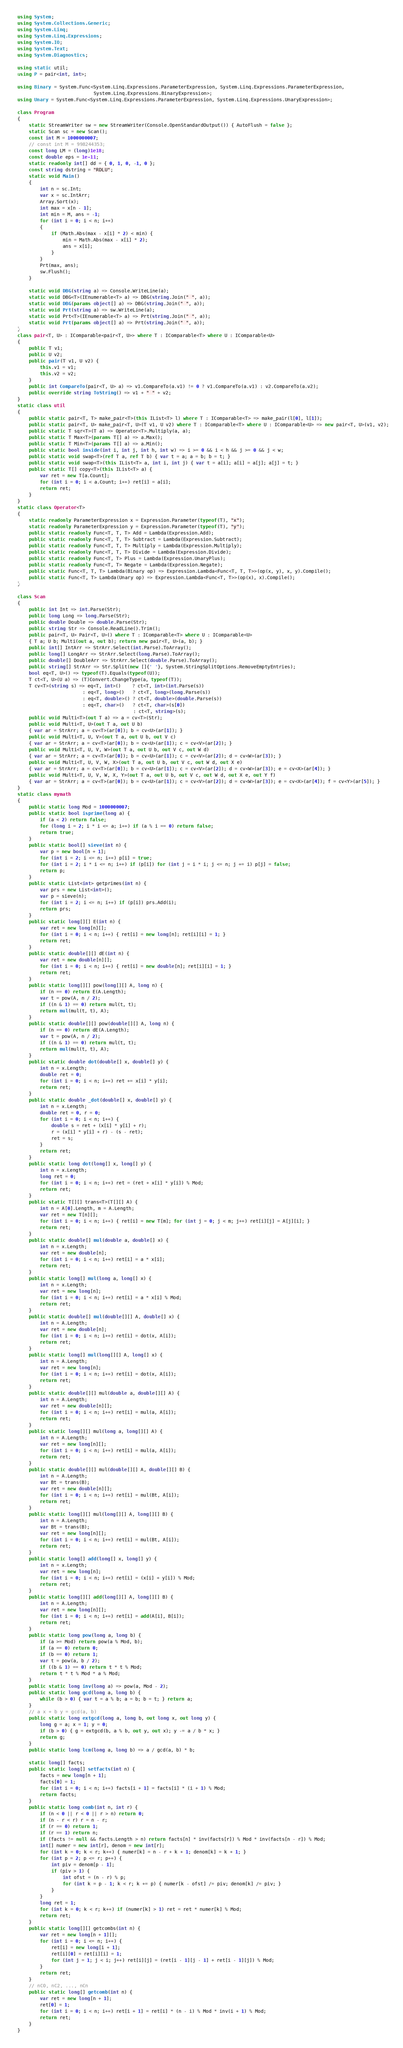<code> <loc_0><loc_0><loc_500><loc_500><_C#_>using System;
using System.Collections.Generic;
using System.Linq;
using System.Linq.Expressions;
using System.IO;
using System.Text;
using System.Diagnostics;

using static util;
using P = pair<int, int>;

using Binary = System.Func<System.Linq.Expressions.ParameterExpression, System.Linq.Expressions.ParameterExpression,
                           System.Linq.Expressions.BinaryExpression>;
using Unary = System.Func<System.Linq.Expressions.ParameterExpression, System.Linq.Expressions.UnaryExpression>;

class Program
{
    static StreamWriter sw = new StreamWriter(Console.OpenStandardOutput()) { AutoFlush = false };
    static Scan sc = new Scan();
    const int M = 1000000007;
    // const int M = 998244353;
    const long LM = (long)1e18;
    const double eps = 1e-11;
    static readonly int[] dd = { 0, 1, 0, -1, 0 };
    const string dstring = "RDLU";
    static void Main()
    {
        int n = sc.Int;
        var x = sc.IntArr;
        Array.Sort(x);
        int max = x[n - 1];
        int min = M, ans = -1;
        for (int i = 0; i < n; i++)
        {
            if (Math.Abs(max - x[i] * 2) < min) {
                min = Math.Abs(max - x[i] * 2);
                ans = x[i];
            }
        }
        Prt(max, ans);
        sw.Flush();
    }

    static void DBG(string a) => Console.WriteLine(a);
    static void DBG<T>(IEnumerable<T> a) => DBG(string.Join(" ", a));
    static void DBG(params object[] a) => DBG(string.Join(" ", a));
    static void Prt(string a) => sw.WriteLine(a);
    static void Prt<T>(IEnumerable<T> a) => Prt(string.Join(" ", a));
    static void Prt(params object[] a) => Prt(string.Join(" ", a));
}
class pair<T, U> : IComparable<pair<T, U>> where T : IComparable<T> where U : IComparable<U>
{
    public T v1;
    public U v2;
    public pair(T v1, U v2) {
        this.v1 = v1;
        this.v2 = v2;
    }
    public int CompareTo(pair<T, U> a) => v1.CompareTo(a.v1) != 0 ? v1.CompareTo(a.v1) : v2.CompareTo(a.v2);
    public override string ToString() => v1 + " " + v2;
}
static class util
{
    public static pair<T, T> make_pair<T>(this IList<T> l) where T : IComparable<T> => make_pair(l[0], l[1]);
    public static pair<T, U> make_pair<T, U>(T v1, U v2) where T : IComparable<T> where U : IComparable<U> => new pair<T, U>(v1, v2);
    public static T sqr<T>(T a) => Operator<T>.Multiply(a, a);
    public static T Max<T>(params T[] a) => a.Max();
    public static T Min<T>(params T[] a) => a.Min();
    public static bool inside(int i, int j, int h, int w) => i >= 0 && i < h && j >= 0 && j < w;
    public static void swap<T>(ref T a, ref T b) { var t = a; a = b; b = t; }
    public static void swap<T>(this IList<T> a, int i, int j) { var t = a[i]; a[i] = a[j]; a[j] = t; }
    public static T[] copy<T>(this IList<T> a) {
        var ret = new T[a.Count];
        for (int i = 0; i < a.Count; i++) ret[i] = a[i];
        return ret;
    }
}
static class Operator<T>
{
    static readonly ParameterExpression x = Expression.Parameter(typeof(T), "x");
    static readonly ParameterExpression y = Expression.Parameter(typeof(T), "y");
    public static readonly Func<T, T, T> Add = Lambda(Expression.Add);
    public static readonly Func<T, T, T> Subtract = Lambda(Expression.Subtract);
    public static readonly Func<T, T, T> Multiply = Lambda(Expression.Multiply);
    public static readonly Func<T, T, T> Divide = Lambda(Expression.Divide);
    public static readonly Func<T, T> Plus = Lambda(Expression.UnaryPlus);
    public static readonly Func<T, T> Negate = Lambda(Expression.Negate);
    public static Func<T, T, T> Lambda(Binary op) => Expression.Lambda<Func<T, T, T>>(op(x, y), x, y).Compile();
    public static Func<T, T> Lambda(Unary op) => Expression.Lambda<Func<T, T>>(op(x), x).Compile();
}

class Scan
{
    public int Int => int.Parse(Str);
    public long Long => long.Parse(Str);
    public double Double => double.Parse(Str);
    public string Str => Console.ReadLine().Trim();
    public pair<T, U> Pair<T, U>() where T : IComparable<T> where U : IComparable<U>
    { T a; U b; Multi(out a, out b); return new pair<T, U>(a, b); }
    public int[] IntArr => StrArr.Select(int.Parse).ToArray();
    public long[] LongArr => StrArr.Select(long.Parse).ToArray();
    public double[] DoubleArr => StrArr.Select(double.Parse).ToArray();
    public string[] StrArr => Str.Split(new []{' '}, System.StringSplitOptions.RemoveEmptyEntries);
    bool eq<T, U>() => typeof(T).Equals(typeof(U));
    T ct<T, U>(U a) => (T)Convert.ChangeType(a, typeof(T));
    T cv<T>(string s) => eq<T, int>()    ? ct<T, int>(int.Parse(s))
                       : eq<T, long>()   ? ct<T, long>(long.Parse(s))
                       : eq<T, double>() ? ct<T, double>(double.Parse(s))
                       : eq<T, char>()   ? ct<T, char>(s[0])
                                         : ct<T, string>(s);
    public void Multi<T>(out T a) => a = cv<T>(Str);
    public void Multi<T, U>(out T a, out U b)
    { var ar = StrArr; a = cv<T>(ar[0]); b = cv<U>(ar[1]); }
    public void Multi<T, U, V>(out T a, out U b, out V c)
    { var ar = StrArr; a = cv<T>(ar[0]); b = cv<U>(ar[1]); c = cv<V>(ar[2]); }
    public void Multi<T, U, V, W>(out T a, out U b, out V c, out W d)
    { var ar = StrArr; a = cv<T>(ar[0]); b = cv<U>(ar[1]); c = cv<V>(ar[2]); d = cv<W>(ar[3]); }
    public void Multi<T, U, V, W, X>(out T a, out U b, out V c, out W d, out X e)
    { var ar = StrArr; a = cv<T>(ar[0]); b = cv<U>(ar[1]); c = cv<V>(ar[2]); d = cv<W>(ar[3]); e = cv<X>(ar[4]); }
    public void Multi<T, U, V, W, X, Y>(out T a, out U b, out V c, out W d, out X e, out Y f)
    { var ar = StrArr; a = cv<T>(ar[0]); b = cv<U>(ar[1]); c = cv<V>(ar[2]); d = cv<W>(ar[3]); e = cv<X>(ar[4]); f = cv<Y>(ar[5]); }
}
static class mymath
{
    public static long Mod = 1000000007;
    public static bool isprime(long a) {
        if (a < 2) return false;
        for (long i = 2; i * i <= a; i++) if (a % i == 0) return false;
        return true;
    }
    public static bool[] sieve(int n) {
        var p = new bool[n + 1];
        for (int i = 2; i <= n; i++) p[i] = true;
        for (int i = 2; i * i <= n; i++) if (p[i]) for (int j = i * i; j <= n; j += i) p[j] = false;
        return p;
    }
    public static List<int> getprimes(int n) {
        var prs = new List<int>();
        var p = sieve(n);
        for (int i = 2; i <= n; i++) if (p[i]) prs.Add(i);
        return prs;
    }
    public static long[][] E(int n) {
        var ret = new long[n][];
        for (int i = 0; i < n; i++) { ret[i] = new long[n]; ret[i][i] = 1; }
        return ret;
    }
    public static double[][] dE(int n) {
        var ret = new double[n][];
        for (int i = 0; i < n; i++) { ret[i] = new double[n]; ret[i][i] = 1; }
        return ret;
    }
    public static long[][] pow(long[][] A, long n) {
        if (n == 0) return E(A.Length);
        var t = pow(A, n / 2);
        if ((n & 1) == 0) return mul(t, t);
        return mul(mul(t, t), A);
    }
    public static double[][] pow(double[][] A, long n) {
        if (n == 0) return dE(A.Length);
        var t = pow(A, n / 2);
        if ((n & 1) == 0) return mul(t, t);
        return mul(mul(t, t), A);
    }
    public static double dot(double[] x, double[] y) {
        int n = x.Length;
        double ret = 0;
        for (int i = 0; i < n; i++) ret += x[i] * y[i];
        return ret;
    }
    public static double _dot(double[] x, double[] y) {
        int n = x.Length;
        double ret = 0, r = 0;
        for (int i = 0; i < n; i++) {
            double s = ret + (x[i] * y[i] + r);
            r = (x[i] * y[i] + r) - (s - ret);
            ret = s;
        }
        return ret;
    }
    public static long dot(long[] x, long[] y) {
        int n = x.Length;
        long ret = 0;
        for (int i = 0; i < n; i++) ret = (ret + x[i] * y[i]) % Mod;
        return ret;
    }
    public static T[][] trans<T>(T[][] A) {
        int n = A[0].Length, m = A.Length;
        var ret = new T[n][];
        for (int i = 0; i < n; i++) { ret[i] = new T[m]; for (int j = 0; j < m; j++) ret[i][j] = A[j][i]; }
        return ret;
    }
    public static double[] mul(double a, double[] x) {
        int n = x.Length;
        var ret = new double[n];
        for (int i = 0; i < n; i++) ret[i] = a * x[i];
        return ret;
    }
    public static long[] mul(long a, long[] x) {
        int n = x.Length;
        var ret = new long[n];
        for (int i = 0; i < n; i++) ret[i] = a * x[i] % Mod;
        return ret;
    }
    public static double[] mul(double[][] A, double[] x) {
        int n = A.Length;
        var ret = new double[n];
        for (int i = 0; i < n; i++) ret[i] = dot(x, A[i]);
        return ret;
    }
    public static long[] mul(long[][] A, long[] x) {
        int n = A.Length;
        var ret = new long[n];
        for (int i = 0; i < n; i++) ret[i] = dot(x, A[i]);
        return ret;
    }
    public static double[][] mul(double a, double[][] A) {
        int n = A.Length;
        var ret = new double[n][];
        for (int i = 0; i < n; i++) ret[i] = mul(a, A[i]);
        return ret;
    }
    public static long[][] mul(long a, long[][] A) {
        int n = A.Length;
        var ret = new long[n][];
        for (int i = 0; i < n; i++) ret[i] = mul(a, A[i]);
        return ret;
    }
    public static double[][] mul(double[][] A, double[][] B) {
        int n = A.Length;
        var Bt = trans(B);
        var ret = new double[n][];
        for (int i = 0; i < n; i++) ret[i] = mul(Bt, A[i]);
        return ret;
    }
    public static long[][] mul(long[][] A, long[][] B) {
        int n = A.Length;
        var Bt = trans(B);
        var ret = new long[n][];
        for (int i = 0; i < n; i++) ret[i] = mul(Bt, A[i]);
        return ret;
    }
    public static long[] add(long[] x, long[] y) {
        int n = x.Length;
        var ret = new long[n];
        for (int i = 0; i < n; i++) ret[i] = (x[i] + y[i]) % Mod;
        return ret;
    }
    public static long[][] add(long[][] A, long[][] B) {
        int n = A.Length;
        var ret = new long[n][];
        for (int i = 0; i < n; i++) ret[i] = add(A[i], B[i]);
        return ret;
    }
    public static long pow(long a, long b) {
        if (a >= Mod) return pow(a % Mod, b);
        if (a == 0) return 0;
        if (b == 0) return 1;
        var t = pow(a, b / 2);
        if ((b & 1) == 0) return t * t % Mod;
        return t * t % Mod * a % Mod;
    }
    public static long inv(long a) => pow(a, Mod - 2);
    public static long gcd(long a, long b) {
        while (b > 0) { var t = a % b; a = b; b = t; } return a;
    }
    // a x + b y = gcd(a, b)
    public static long extgcd(long a, long b, out long x, out long y) {
        long g = a; x = 1; y = 0;
        if (b > 0) { g = extgcd(b, a % b, out y, out x); y -= a / b * x; }
        return g;
    }
    public static long lcm(long a, long b) => a / gcd(a, b) * b;

    static long[] facts;
    public static long[] setfacts(int n) {
        facts = new long[n + 1];
        facts[0] = 1;
        for (int i = 0; i < n; i++) facts[i + 1] = facts[i] * (i + 1) % Mod;
        return facts;
    }
    public static long comb(int n, int r) {
        if (n < 0 || r < 0 || r > n) return 0;
        if (n - r < r) r = n - r;
        if (r == 0) return 1;
        if (r == 1) return n;
        if (facts != null && facts.Length > n) return facts[n] * inv(facts[r]) % Mod * inv(facts[n - r]) % Mod;
        int[] numer = new int[r], denom = new int[r];
        for (int k = 0; k < r; k++) { numer[k] = n - r + k + 1; denom[k] = k + 1; }
        for (int p = 2; p <= r; p++) {
            int piv = denom[p - 1];
            if (piv > 1) {
                int ofst = (n - r) % p;
                for (int k = p - 1; k < r; k += p) { numer[k - ofst] /= piv; denom[k] /= piv; }
            }
        }
        long ret = 1;
        for (int k = 0; k < r; k++) if (numer[k] > 1) ret = ret * numer[k] % Mod;
        return ret;
    }
    public static long[][] getcombs(int n) {
        var ret = new long[n + 1][];
        for (int i = 0; i <= n; i++) {
            ret[i] = new long[i + 1];
            ret[i][0] = ret[i][i] = 1;
            for (int j = 1; j < i; j++) ret[i][j] = (ret[i - 1][j - 1] + ret[i - 1][j]) % Mod;
        }
        return ret;
    }
    // nC0, nC2, ..., nCn
    public static long[] getcomb(int n) {
        var ret = new long[n + 1];
        ret[0] = 1;
        for (int i = 0; i < n; i++) ret[i + 1] = ret[i] * (n - i) % Mod * inv(i + 1) % Mod;
        return ret;
    }
}
</code> 